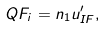<formula> <loc_0><loc_0><loc_500><loc_500>Q F _ { i } = n _ { 1 } u _ { I F } ^ { \prime } ,</formula> 